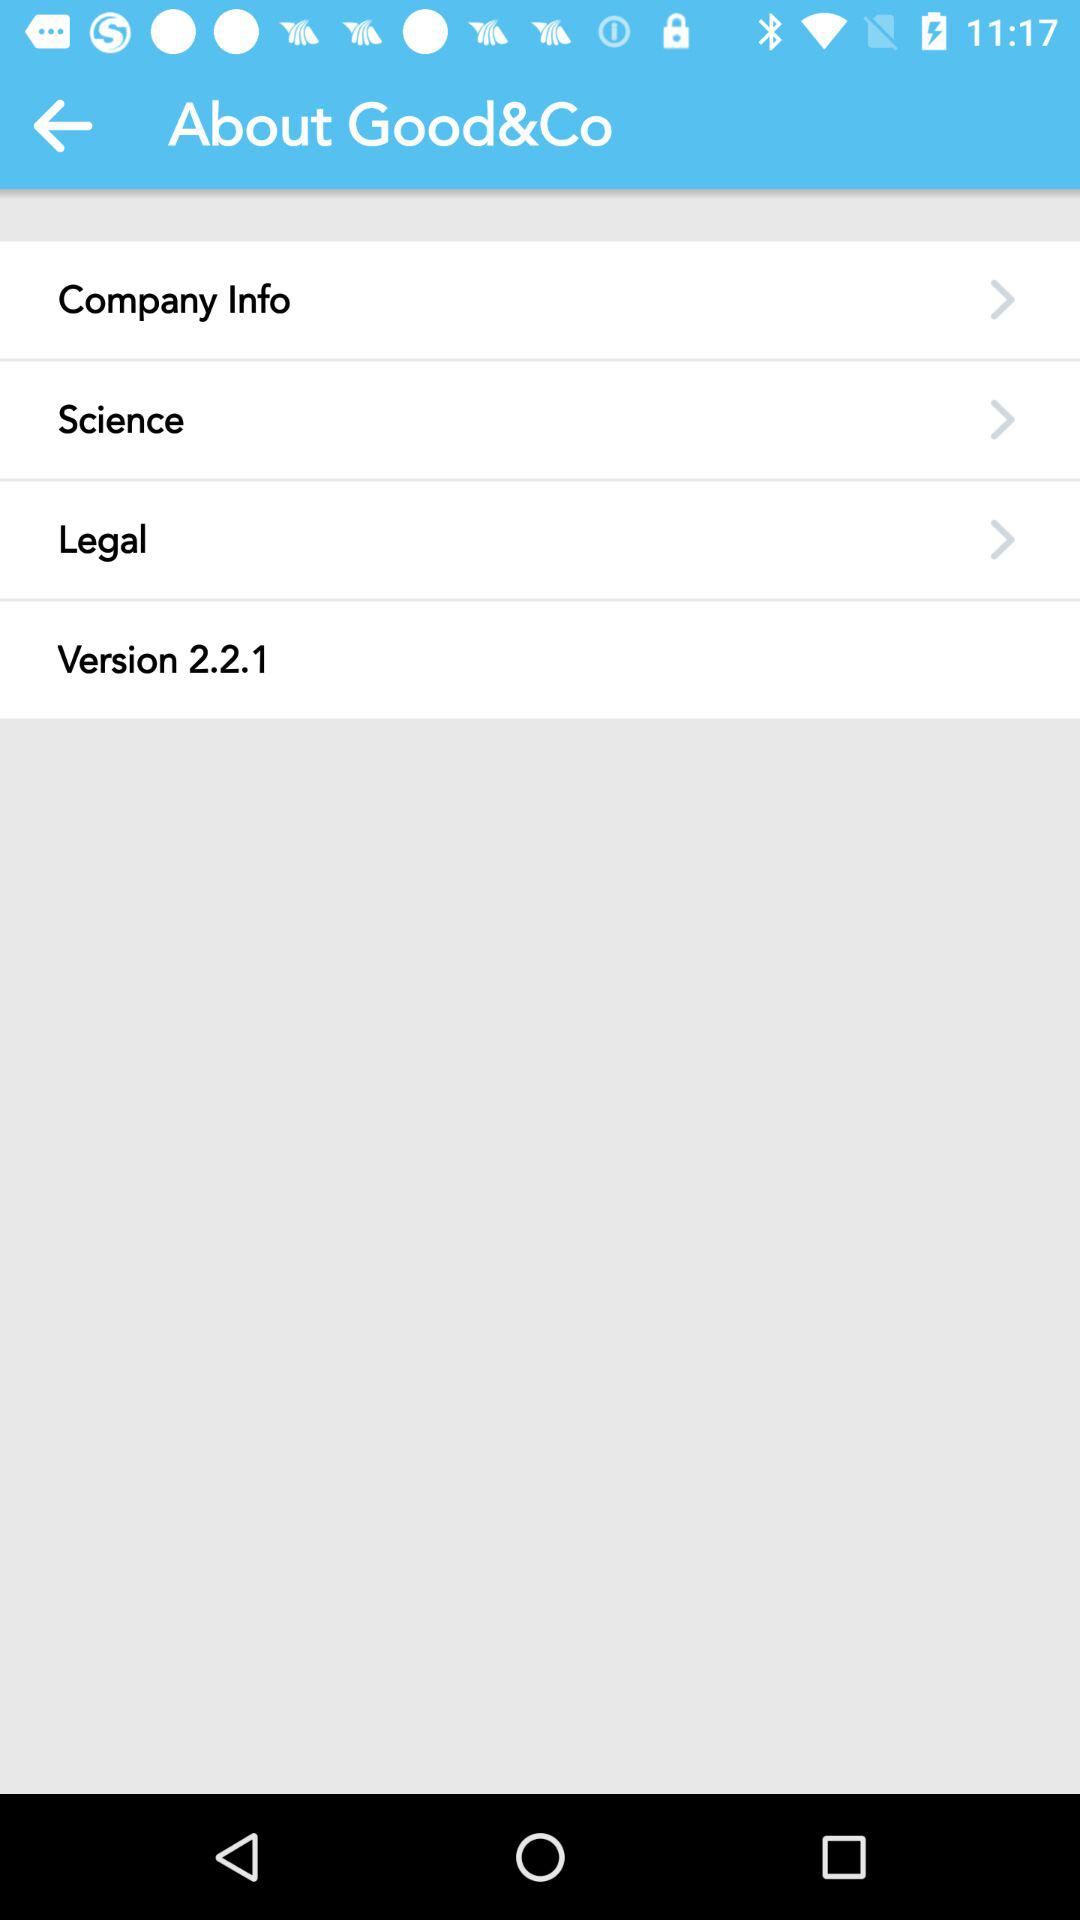What is the name of the application? The name of the application is "Good&Co". 